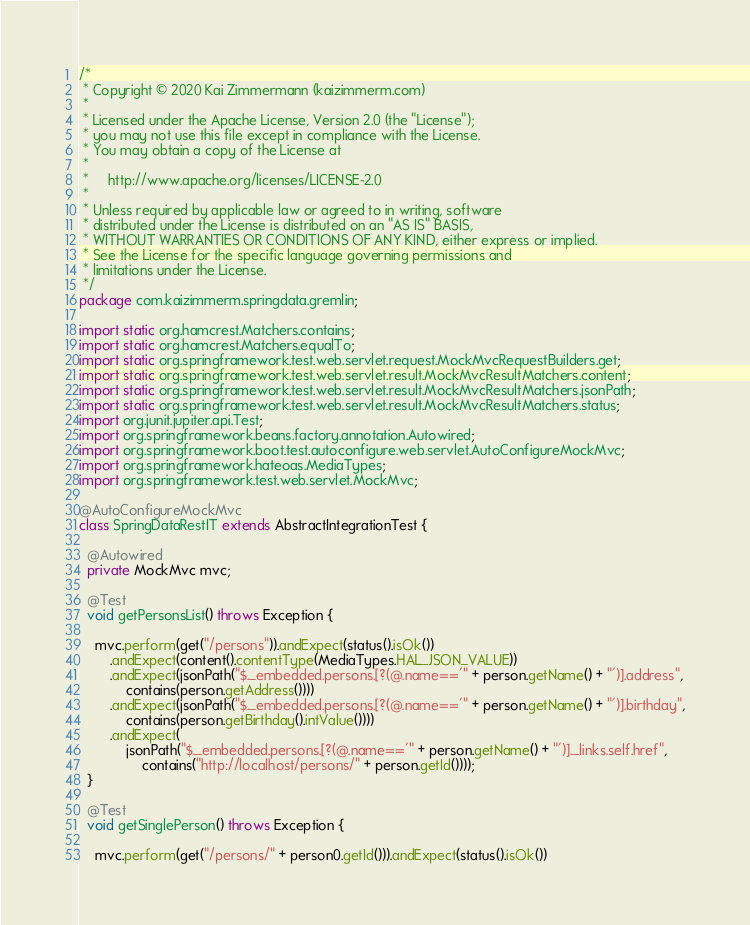<code> <loc_0><loc_0><loc_500><loc_500><_Java_>/*
 * Copyright © 2020 Kai Zimmermann (kaizimmerm.com)
 *
 * Licensed under the Apache License, Version 2.0 (the "License");
 * you may not use this file except in compliance with the License.
 * You may obtain a copy of the License at
 *
 *     http://www.apache.org/licenses/LICENSE-2.0
 *
 * Unless required by applicable law or agreed to in writing, software
 * distributed under the License is distributed on an "AS IS" BASIS,
 * WITHOUT WARRANTIES OR CONDITIONS OF ANY KIND, either express or implied.
 * See the License for the specific language governing permissions and
 * limitations under the License.
 */
package com.kaizimmerm.springdata.gremlin;

import static org.hamcrest.Matchers.contains;
import static org.hamcrest.Matchers.equalTo;
import static org.springframework.test.web.servlet.request.MockMvcRequestBuilders.get;
import static org.springframework.test.web.servlet.result.MockMvcResultMatchers.content;
import static org.springframework.test.web.servlet.result.MockMvcResultMatchers.jsonPath;
import static org.springframework.test.web.servlet.result.MockMvcResultMatchers.status;
import org.junit.jupiter.api.Test;
import org.springframework.beans.factory.annotation.Autowired;
import org.springframework.boot.test.autoconfigure.web.servlet.AutoConfigureMockMvc;
import org.springframework.hateoas.MediaTypes;
import org.springframework.test.web.servlet.MockMvc;

@AutoConfigureMockMvc
class SpringDataRestIT extends AbstractIntegrationTest {

  @Autowired
  private MockMvc mvc;

  @Test
  void getPersonsList() throws Exception {

    mvc.perform(get("/persons")).andExpect(status().isOk())
        .andExpect(content().contentType(MediaTypes.HAL_JSON_VALUE))
        .andExpect(jsonPath("$._embedded.persons.[?(@.name=='" + person.getName() + "')].address",
            contains(person.getAddress())))
        .andExpect(jsonPath("$._embedded.persons.[?(@.name=='" + person.getName() + "')].birthday",
            contains(person.getBirthday().intValue())))
        .andExpect(
            jsonPath("$._embedded.persons.[?(@.name=='" + person.getName() + "')]._links.self.href",
                contains("http://localhost/persons/" + person.getId())));
  }

  @Test
  void getSinglePerson() throws Exception {

    mvc.perform(get("/persons/" + person0.getId())).andExpect(status().isOk())</code> 